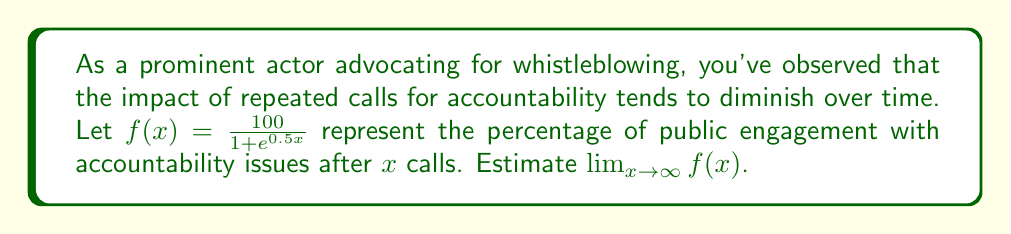Teach me how to tackle this problem. To estimate the limit of $f(x)$ as $x$ approaches infinity, we'll follow these steps:

1) First, let's examine the function:
   $$f(x) = \frac{100}{1 + e^{0.5x}}$$

2) As $x$ increases, $e^{0.5x}$ grows exponentially. This means that as $x \to \infty$, $e^{0.5x} \to \infty$.

3) In the denominator, $1 + e^{0.5x}$ will be dominated by $e^{0.5x}$ as $x \to \infty$. So, for very large $x$, we can approximate:
   $$1 + e^{0.5x} \approx e^{0.5x}$$

4) Therefore, as $x \to \infty$, our function approaches:
   $$f(x) \approx \frac{100}{e^{0.5x}}$$

5) Now, as $x \to \infty$, $e^{0.5x} \to \infty$, so $\frac{100}{e^{0.5x}} \to 0$.

6) Thus, we can conclude:
   $$\lim_{x \to \infty} f(x) = 0$$

This result suggests that as the number of calls for accountability increases indefinitely, the public engagement asymptotically approaches 0%.
Answer: $0$ 